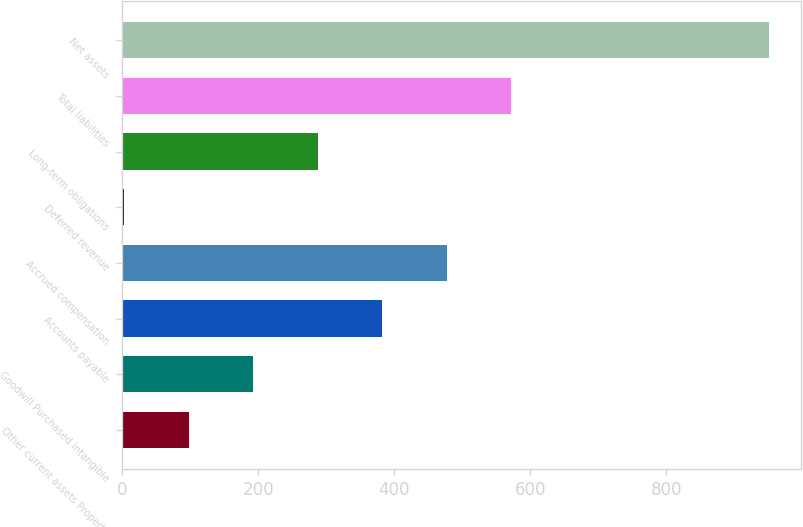Convert chart. <chart><loc_0><loc_0><loc_500><loc_500><bar_chart><fcel>Other current assets Property<fcel>Goodwill Purchased intangible<fcel>Accounts payable<fcel>Accrued compensation<fcel>Deferred revenue<fcel>Long-term obligations<fcel>Total liabilities<fcel>Net assets<nl><fcel>97.8<fcel>192.6<fcel>382.2<fcel>477<fcel>3<fcel>287.4<fcel>571.8<fcel>951<nl></chart> 